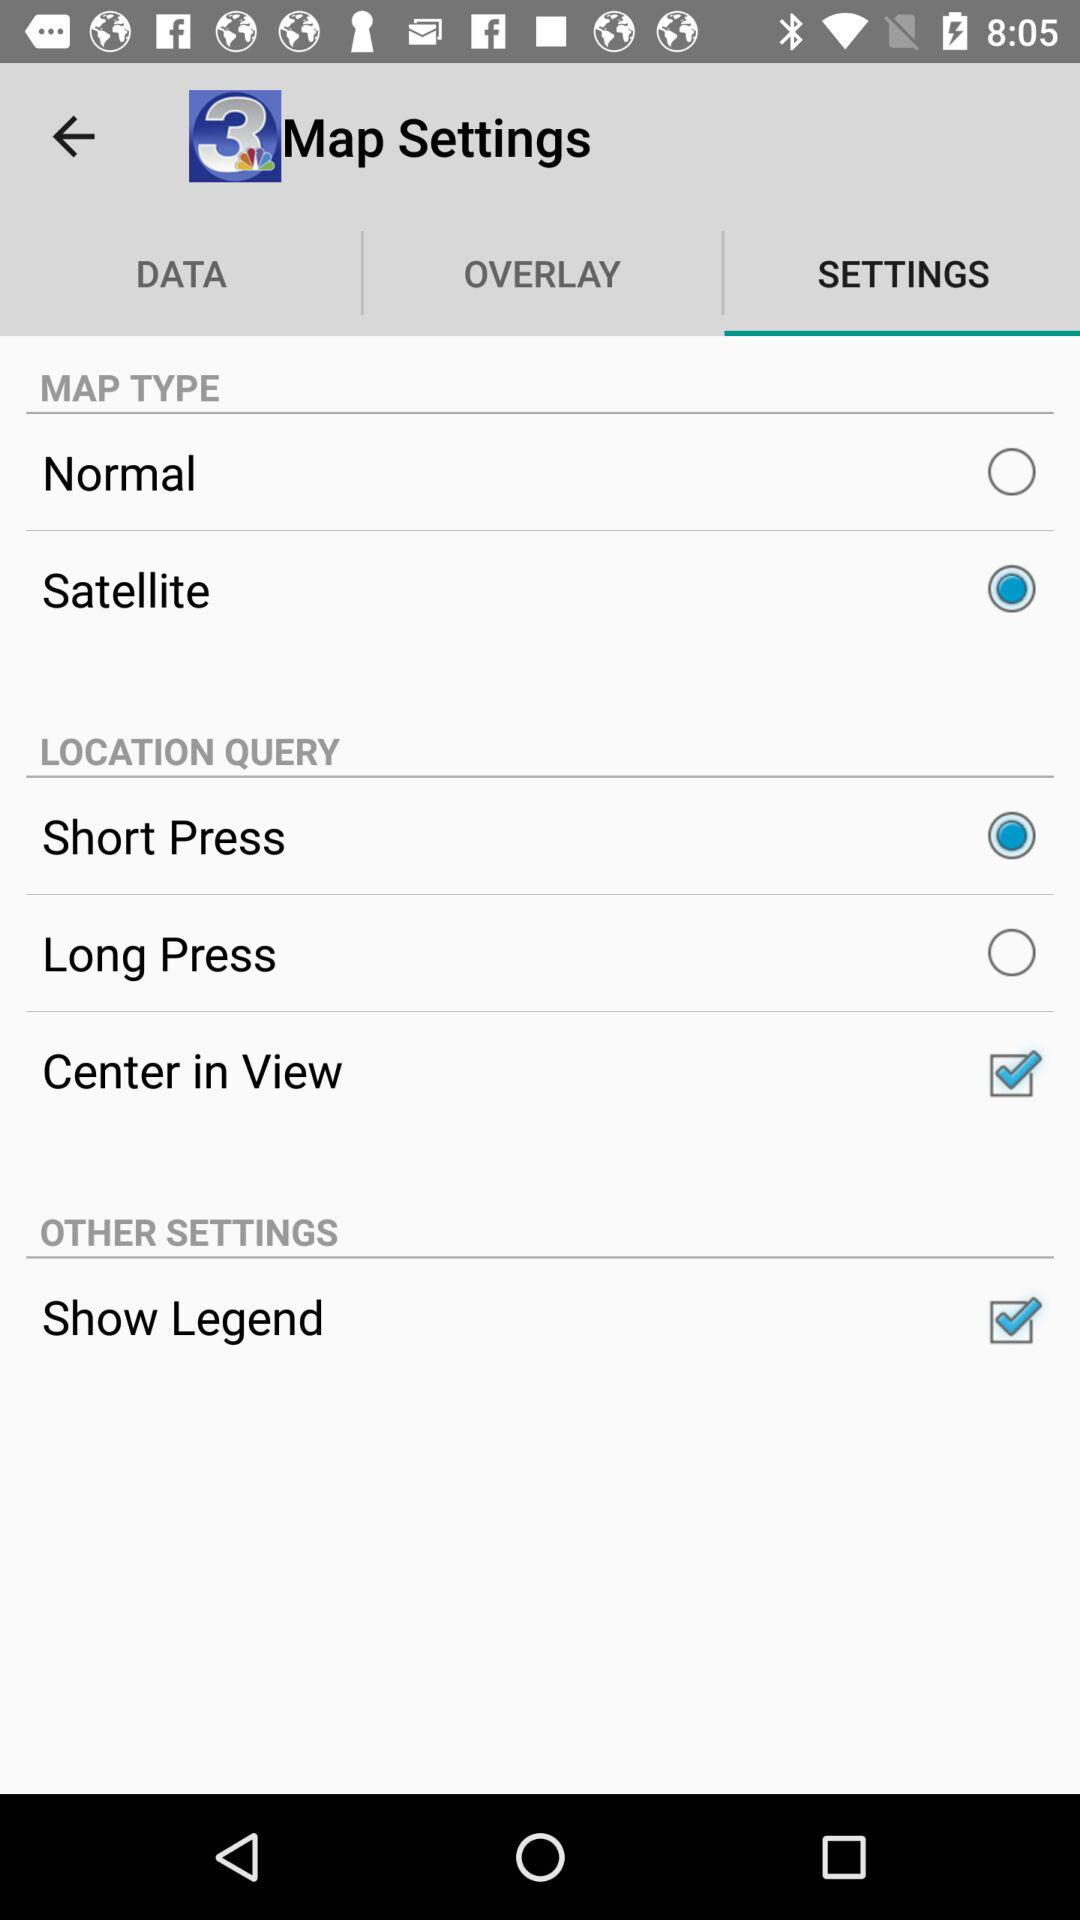What are the options in "OTHER SETTINGS"? The option in "OTHER SETTINGS" is "Show Legend". 